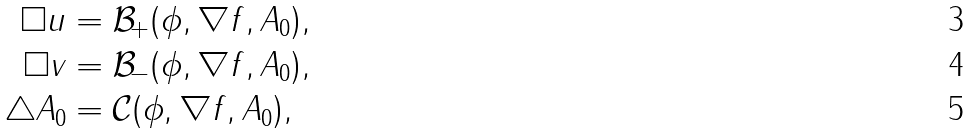<formula> <loc_0><loc_0><loc_500><loc_500>\square u & = \mathcal { B } _ { + } ( \phi , \nabla f , A _ { 0 } ) , \\ \square v & = \mathcal { B } _ { - } ( \phi , \nabla f , A _ { 0 } ) , \\ \triangle A _ { 0 } & = \mathcal { C } ( \phi , \nabla f , A _ { 0 } ) ,</formula> 